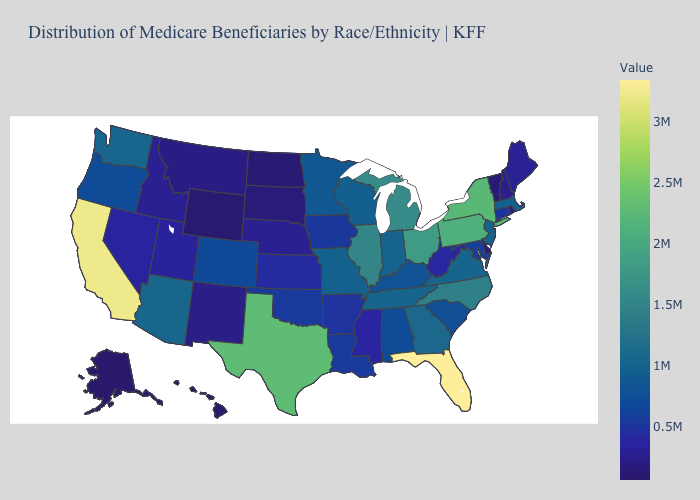Which states have the highest value in the USA?
Answer briefly. Florida. Which states have the lowest value in the USA?
Write a very short answer. Hawaii. Among the states that border Wisconsin , does Michigan have the highest value?
Answer briefly. Yes. Among the states that border Minnesota , which have the lowest value?
Write a very short answer. North Dakota. 